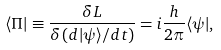<formula> <loc_0><loc_0><loc_500><loc_500>\langle \Pi | \equiv \frac { \delta L } { \delta \left ( d | \psi \rangle / d t \right ) } = i \frac { h } { 2 \pi } \langle \psi | ,</formula> 